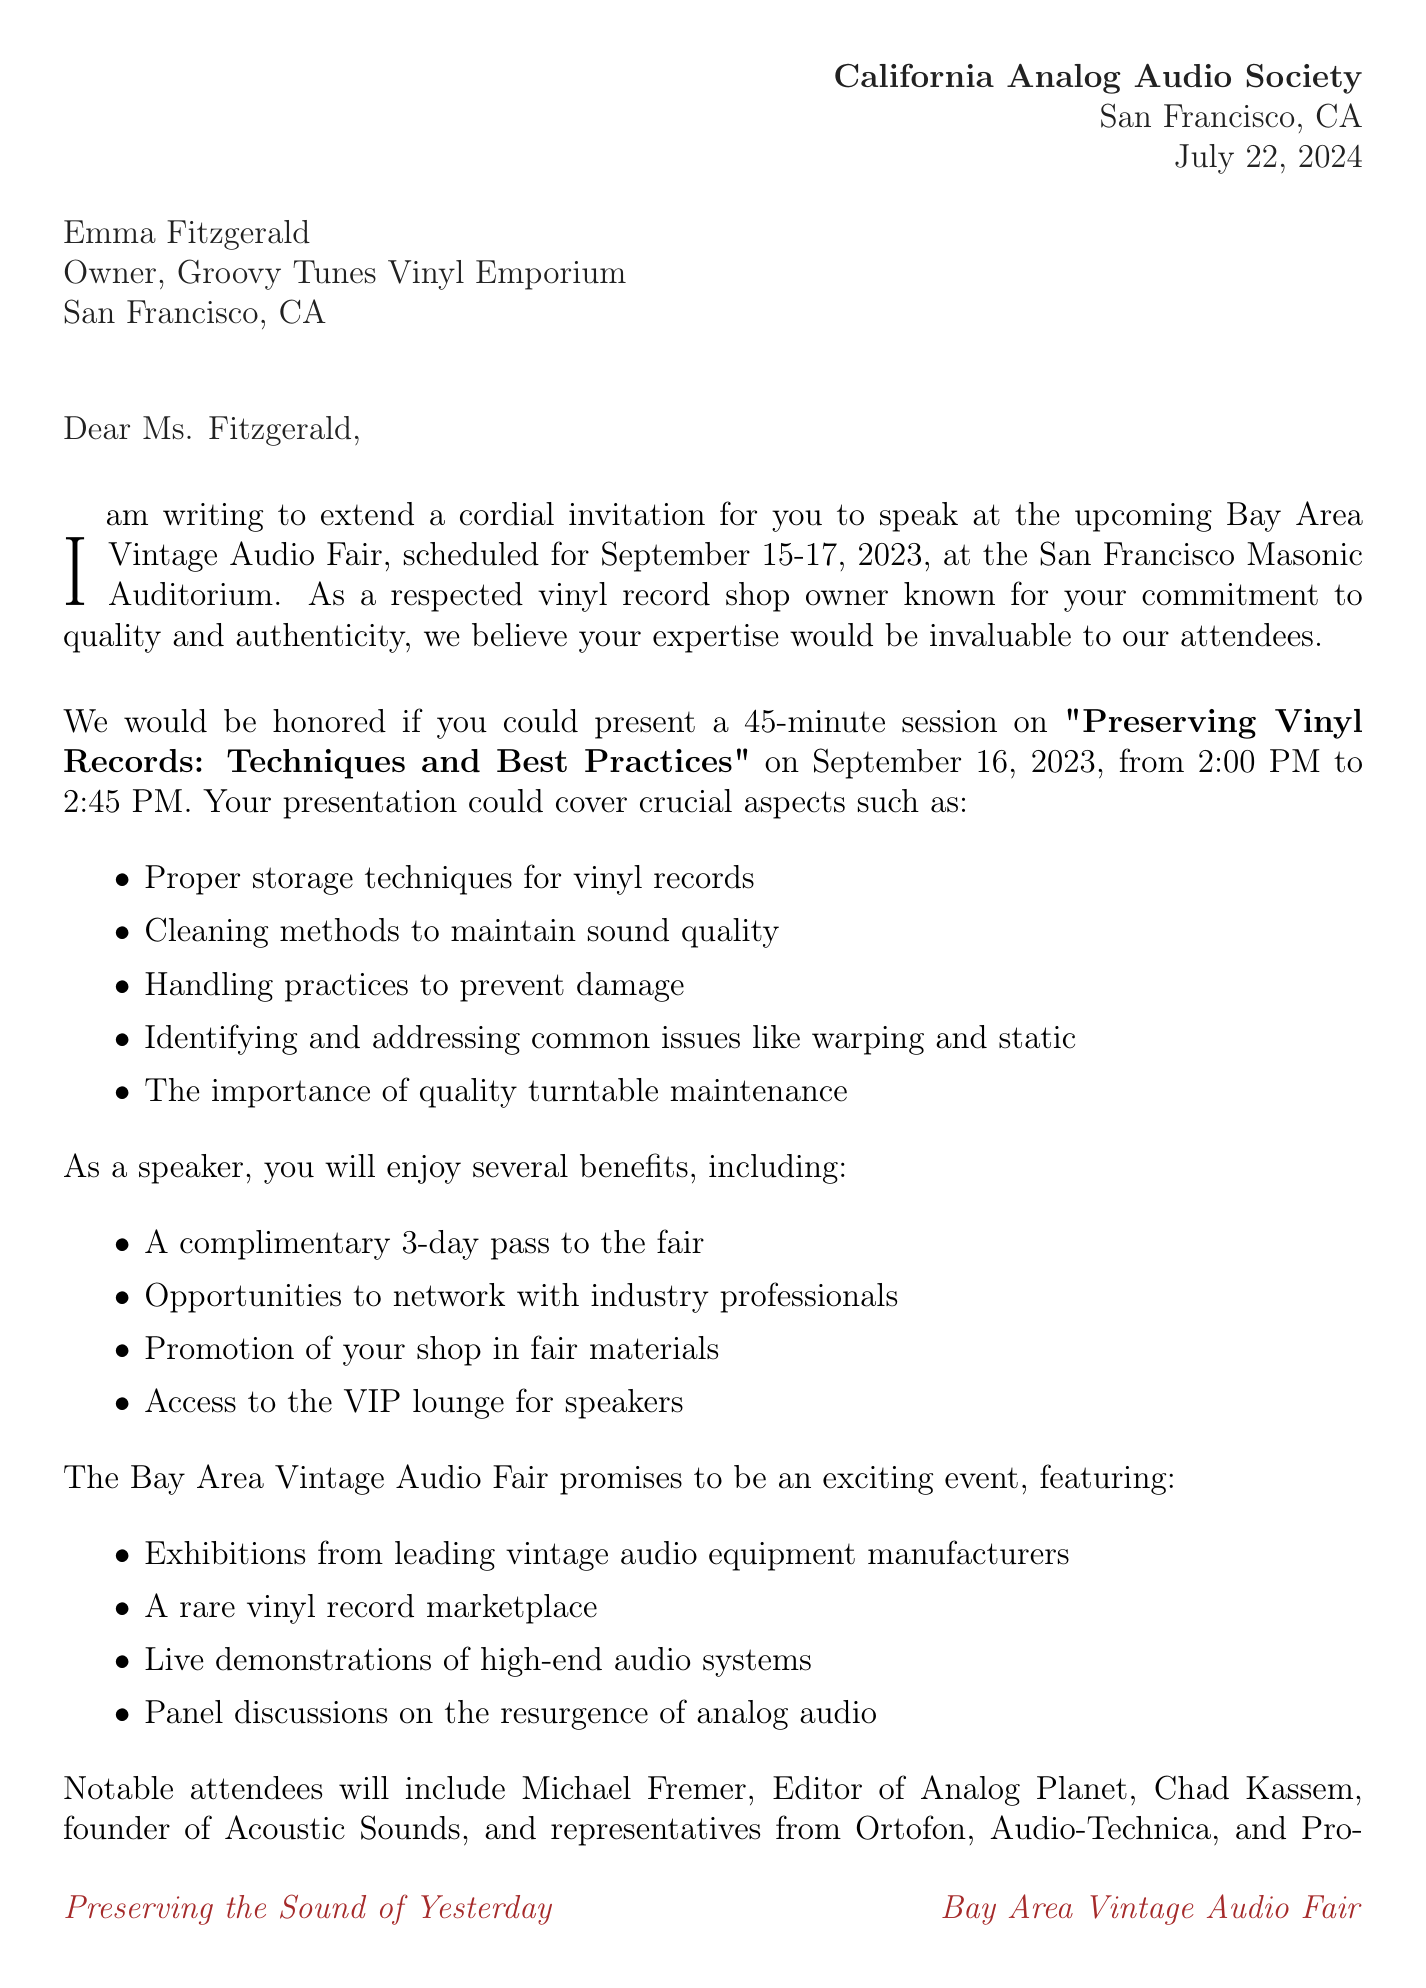What is the name of the event? The name of the event is explicitly stated in the document as "Bay Area Vintage Audio Fair."
Answer: Bay Area Vintage Audio Fair What is the date of the speaking opportunity? The speaking opportunity is scheduled for September 16, 2023, which is mentioned directly in the details.
Answer: September 16, 2023 How long is the presentation? The duration of the presentation is specified as a 45-minute presentation.
Answer: 45-minute presentation Who is the sender of the invitation? The sender of the invitation is identified in the document as Marcus Hendricks.
Answer: Marcus Hendricks What benefits does a speaker receive? The document lists several benefits, the first of which is "A complimentary 3-day pass to the fair."
Answer: A complimentary 3-day pass to the fair What are some of the suggested topics for the presentation? Suggested topics include "Proper storage techniques for vinyl records," a specific topic mentioned in the list.
Answer: Proper storage techniques for vinyl records What is the deadline to RSVP? The RSVP deadline is clearly stated in the invitation details as August 15, 2023.
Answer: August 15, 2023 Which hotel offers discounted rates? The document specifies that discounted rates are available at the nearby Fairmont San Francisco hotel.
Answer: Fairmont San Francisco hotel 